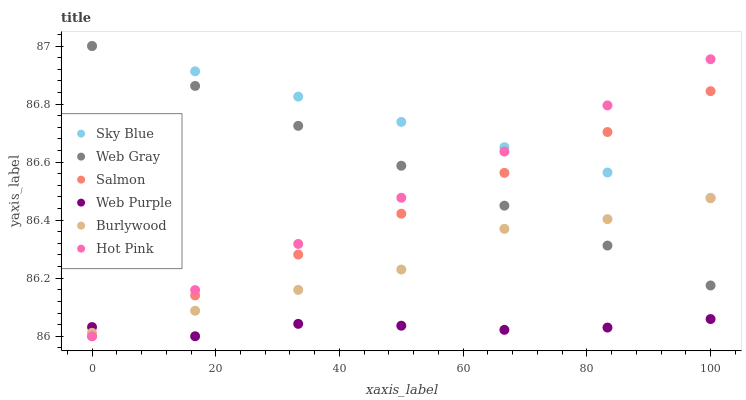Does Web Purple have the minimum area under the curve?
Answer yes or no. Yes. Does Sky Blue have the maximum area under the curve?
Answer yes or no. Yes. Does Burlywood have the minimum area under the curve?
Answer yes or no. No. Does Burlywood have the maximum area under the curve?
Answer yes or no. No. Is Web Gray the smoothest?
Answer yes or no. Yes. Is Burlywood the roughest?
Answer yes or no. Yes. Is Hot Pink the smoothest?
Answer yes or no. No. Is Hot Pink the roughest?
Answer yes or no. No. Does Hot Pink have the lowest value?
Answer yes or no. Yes. Does Burlywood have the lowest value?
Answer yes or no. No. Does Sky Blue have the highest value?
Answer yes or no. Yes. Does Burlywood have the highest value?
Answer yes or no. No. Is Web Purple less than Web Gray?
Answer yes or no. Yes. Is Web Gray greater than Web Purple?
Answer yes or no. Yes. Does Burlywood intersect Salmon?
Answer yes or no. Yes. Is Burlywood less than Salmon?
Answer yes or no. No. Is Burlywood greater than Salmon?
Answer yes or no. No. Does Web Purple intersect Web Gray?
Answer yes or no. No. 